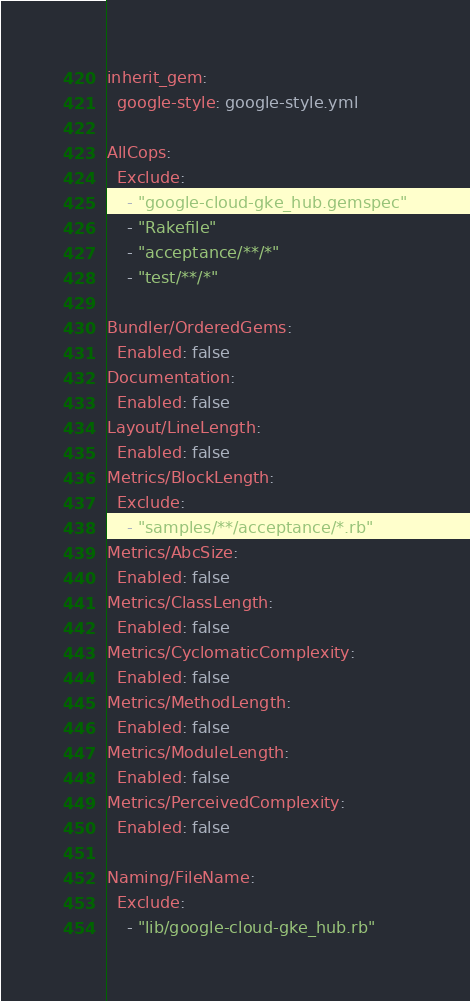Convert code to text. <code><loc_0><loc_0><loc_500><loc_500><_YAML_>inherit_gem:
  google-style: google-style.yml

AllCops:
  Exclude:
    - "google-cloud-gke_hub.gemspec"
    - "Rakefile"
    - "acceptance/**/*"
    - "test/**/*"

Bundler/OrderedGems:
  Enabled: false
Documentation:
  Enabled: false
Layout/LineLength:
  Enabled: false
Metrics/BlockLength:
  Exclude:
    - "samples/**/acceptance/*.rb"
Metrics/AbcSize:
  Enabled: false
Metrics/ClassLength:
  Enabled: false
Metrics/CyclomaticComplexity:
  Enabled: false
Metrics/MethodLength:
  Enabled: false
Metrics/ModuleLength:
  Enabled: false
Metrics/PerceivedComplexity:
  Enabled: false

Naming/FileName:
  Exclude:
    - "lib/google-cloud-gke_hub.rb"
</code> 